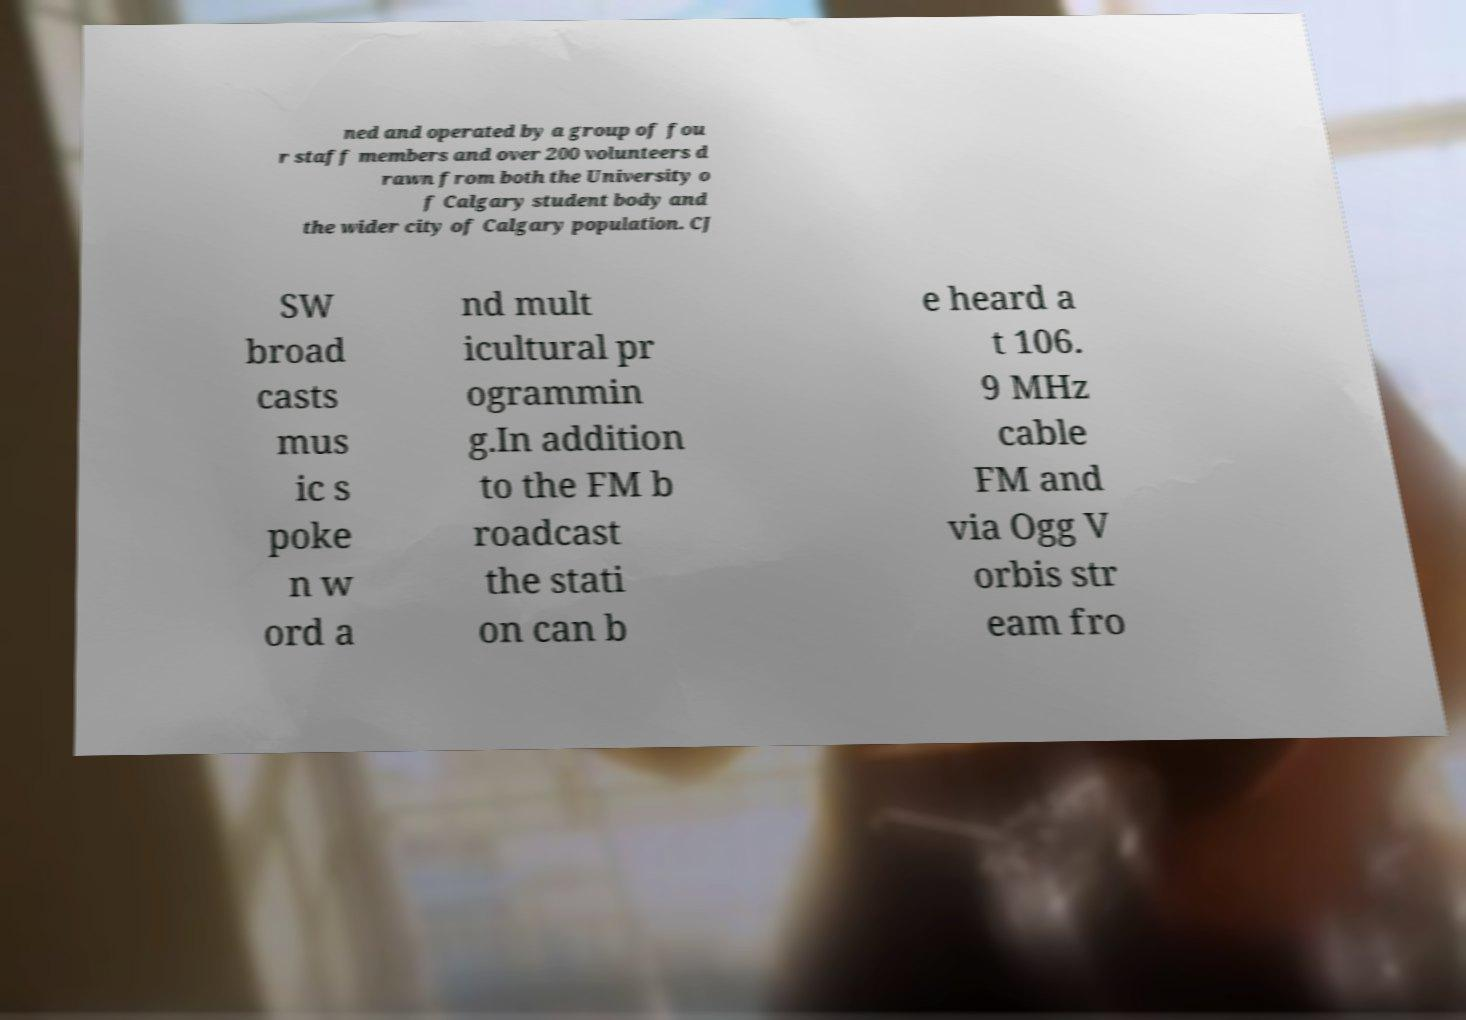What messages or text are displayed in this image? I need them in a readable, typed format. ned and operated by a group of fou r staff members and over 200 volunteers d rawn from both the University o f Calgary student body and the wider city of Calgary population. CJ SW broad casts mus ic s poke n w ord a nd mult icultural pr ogrammin g.In addition to the FM b roadcast the stati on can b e heard a t 106. 9 MHz cable FM and via Ogg V orbis str eam fro 